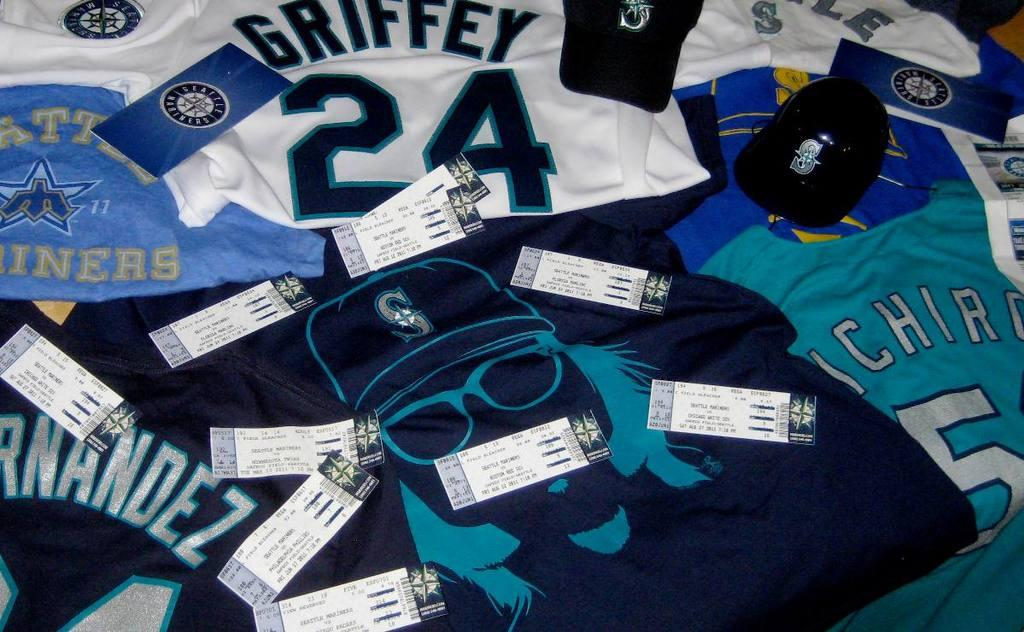What type of clothing items are featured in the image? The image features T-shirts. What specific details can be observed on the T-shirts? There are tabs and caps on the T-shirts. What type of store can be seen in the background of the image? There is no store visible in the image; it only features T-shirts with tabs and caps. Can you describe the duck that is sitting on the T-shirt? There is no duck present in the image; it only features T-shirts with tabs and caps. 